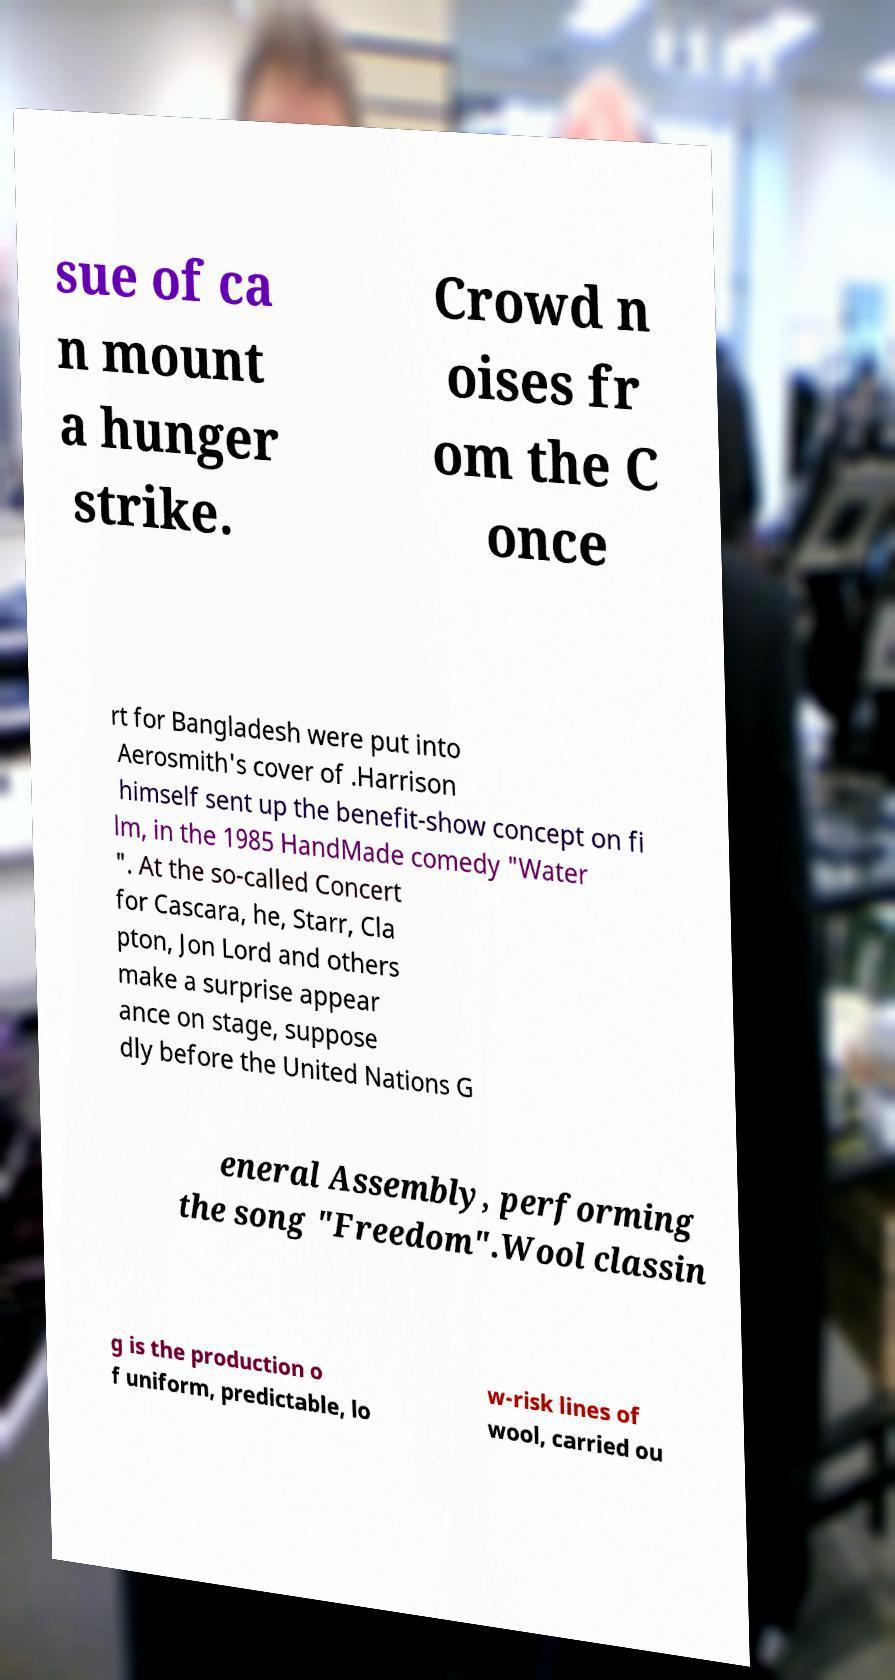Could you assist in decoding the text presented in this image and type it out clearly? sue of ca n mount a hunger strike. Crowd n oises fr om the C once rt for Bangladesh were put into Aerosmith's cover of .Harrison himself sent up the benefit-show concept on fi lm, in the 1985 HandMade comedy "Water ". At the so-called Concert for Cascara, he, Starr, Cla pton, Jon Lord and others make a surprise appear ance on stage, suppose dly before the United Nations G eneral Assembly, performing the song "Freedom".Wool classin g is the production o f uniform, predictable, lo w-risk lines of wool, carried ou 